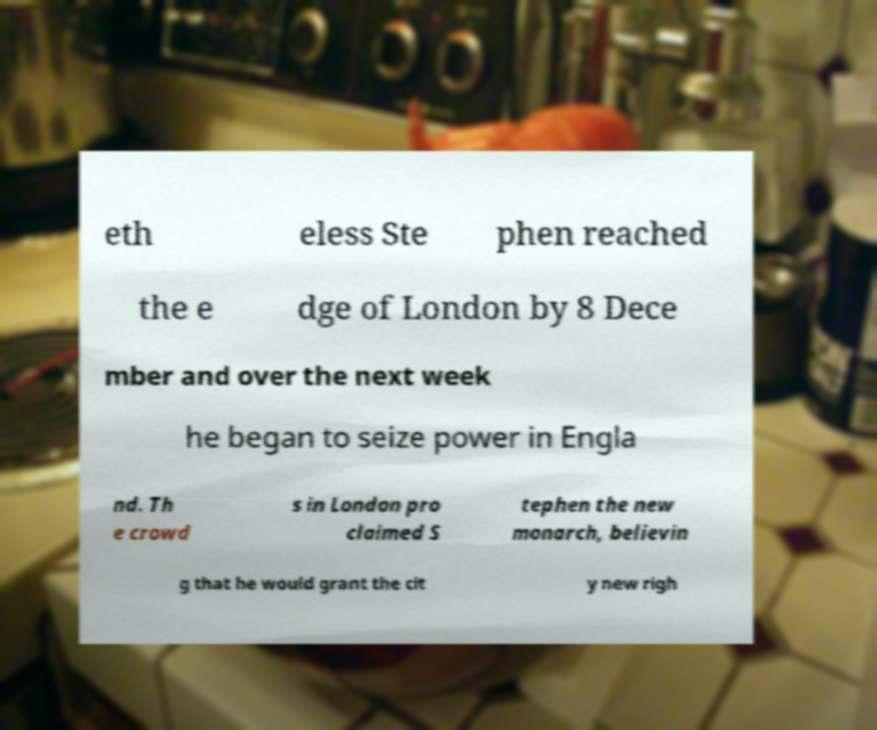Please read and relay the text visible in this image. What does it say? eth eless Ste phen reached the e dge of London by 8 Dece mber and over the next week he began to seize power in Engla nd. Th e crowd s in London pro claimed S tephen the new monarch, believin g that he would grant the cit y new righ 